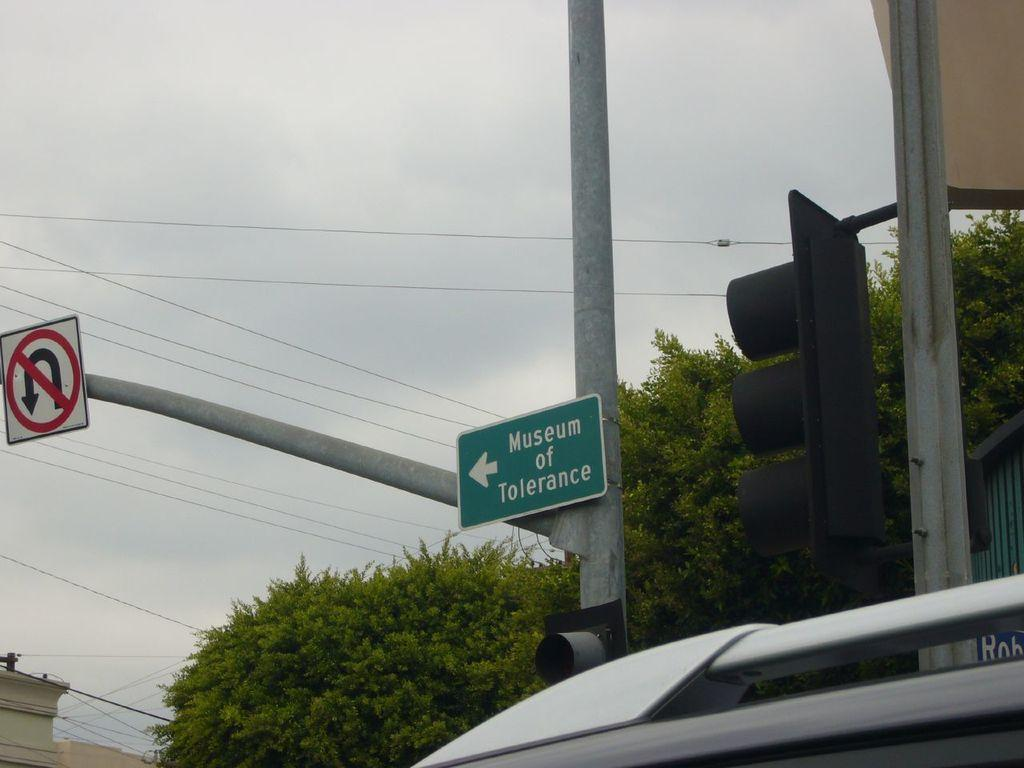What type of board can be seen in the image? There is a direction board and a sign board in the image. What are the poles used for in the image? The poles are likely used to support the wires and traffic signals in the image. What type of vegetation is present in the image? There are trees in the image. What can be seen connected to the poles in the image? There are wires and traffic signals connected to the poles in the image. What other objects can be seen in the image? There are some objects in the image, but their specific nature is not mentioned. What is visible in the background of the image? The sky is visible in the background of the image. Can you tell me how many seeds are planted near the foot of the trees in the image? There is no mention of seeds or feet in the image, so it is not possible to answer this question. 